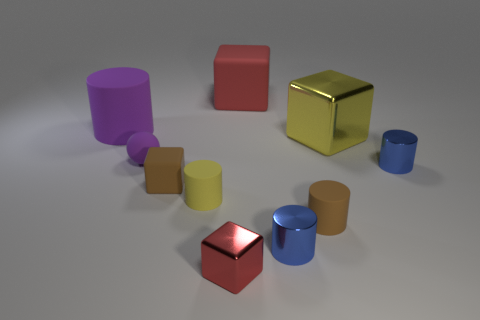Subtract all small red cubes. How many cubes are left? 3 Subtract all purple cubes. How many blue cylinders are left? 2 Subtract all red cubes. How many cubes are left? 2 Subtract 2 cylinders. How many cylinders are left? 3 Subtract all cubes. How many objects are left? 6 Subtract all cyan blocks. Subtract all green cylinders. How many blocks are left? 4 Add 4 cyan rubber cylinders. How many cyan rubber cylinders exist? 4 Subtract 0 blue spheres. How many objects are left? 10 Subtract all yellow matte things. Subtract all tiny brown cubes. How many objects are left? 8 Add 1 blocks. How many blocks are left? 5 